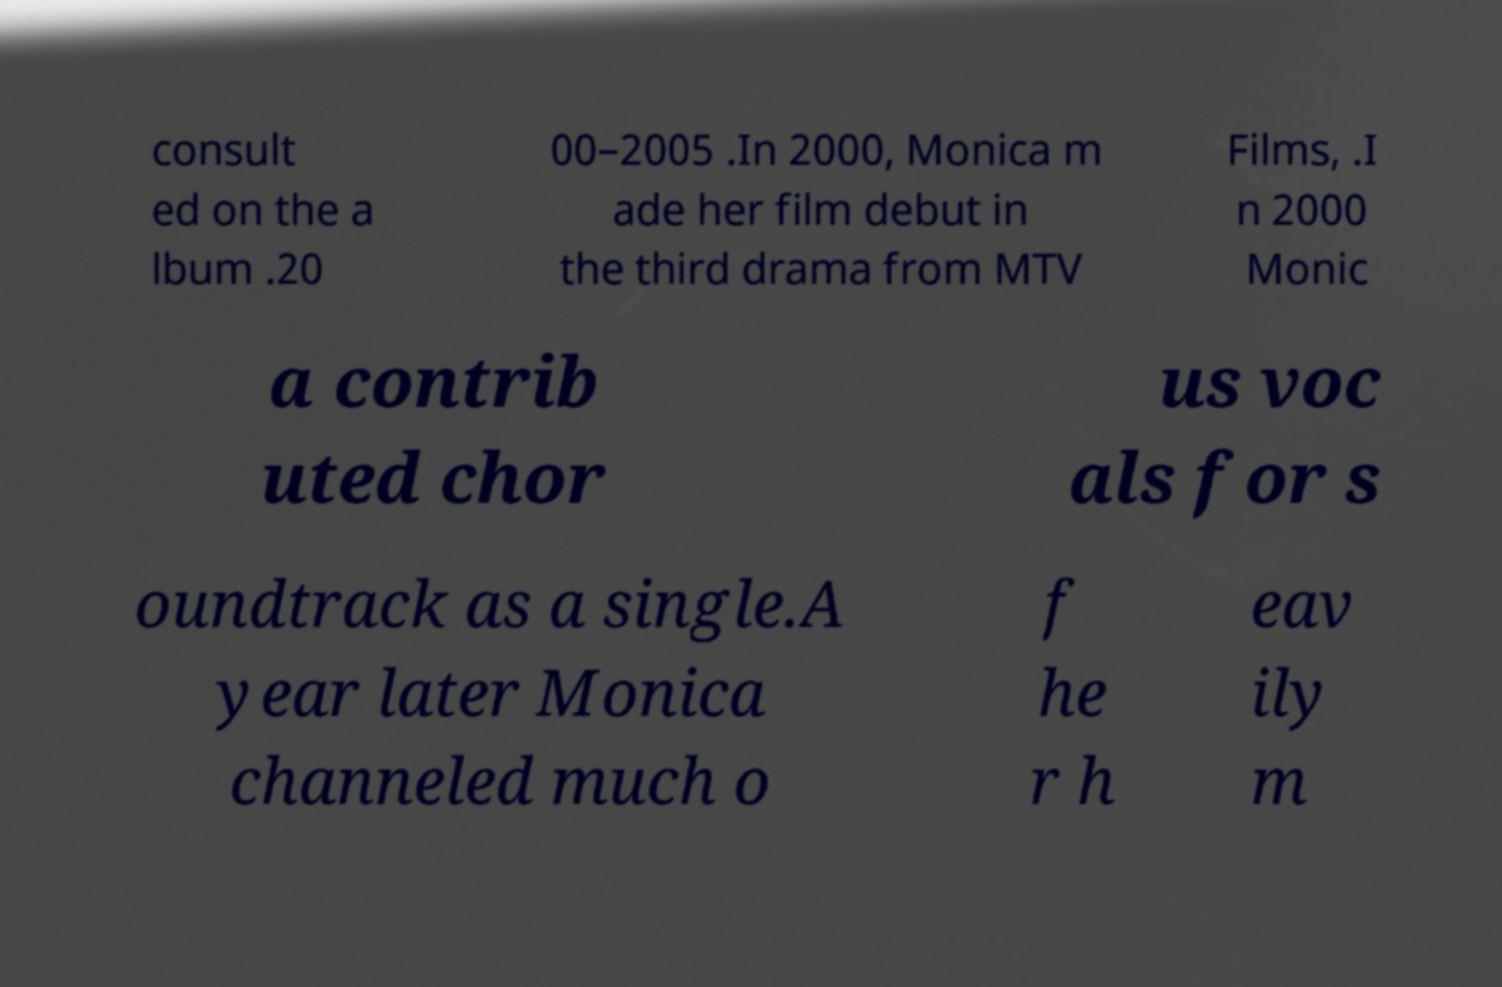Could you extract and type out the text from this image? consult ed on the a lbum .20 00–2005 .In 2000, Monica m ade her film debut in the third drama from MTV Films, .I n 2000 Monic a contrib uted chor us voc als for s oundtrack as a single.A year later Monica channeled much o f he r h eav ily m 